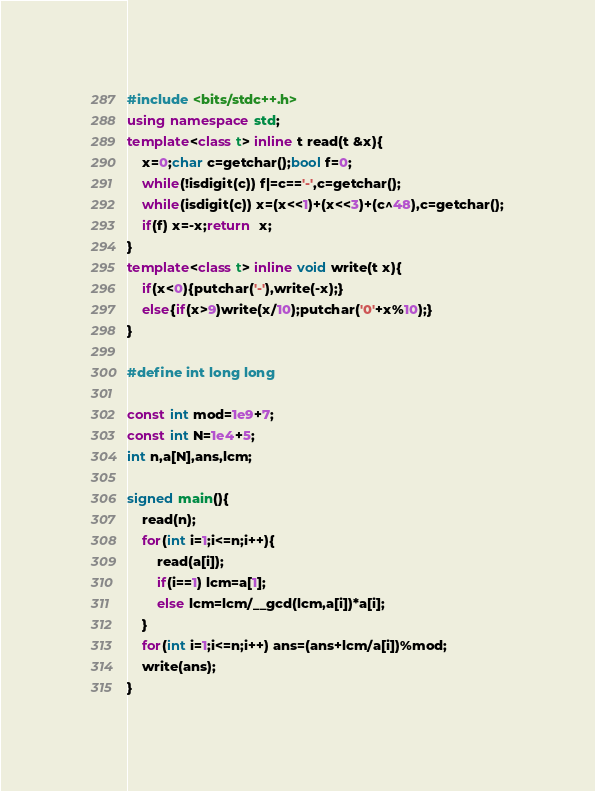<code> <loc_0><loc_0><loc_500><loc_500><_C++_>#include <bits/stdc++.h>
using namespace std;
template<class t> inline t read(t &x){
    x=0;char c=getchar();bool f=0;
    while(!isdigit(c)) f|=c=='-',c=getchar();
    while(isdigit(c)) x=(x<<1)+(x<<3)+(c^48),c=getchar();
    if(f) x=-x;return  x;
}
template<class t> inline void write(t x){
    if(x<0){putchar('-'),write(-x);}
    else{if(x>9)write(x/10);putchar('0'+x%10);}
}

#define int long long

const int mod=1e9+7;
const int N=1e4+5;
int n,a[N],ans,lcm;

signed main(){
	read(n);
	for(int i=1;i<=n;i++){
		read(a[i]);
		if(i==1) lcm=a[1];
		else lcm=lcm/__gcd(lcm,a[i])*a[i];
	}
	for(int i=1;i<=n;i++) ans=(ans+lcm/a[i])%mod;
	write(ans);
}</code> 